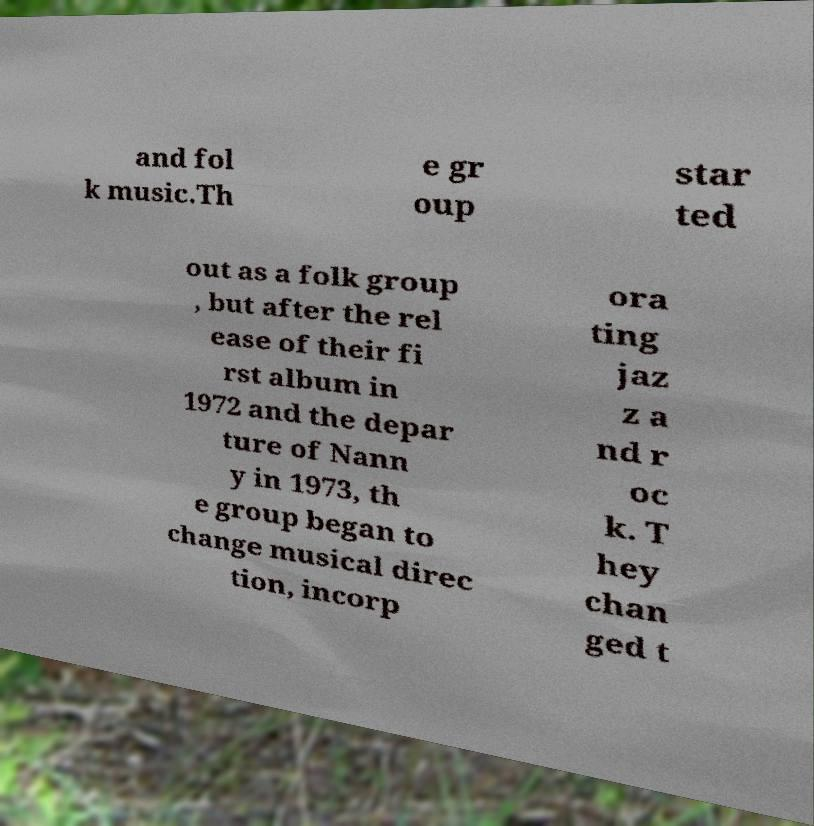I need the written content from this picture converted into text. Can you do that? and fol k music.Th e gr oup star ted out as a folk group , but after the rel ease of their fi rst album in 1972 and the depar ture of Nann y in 1973, th e group began to change musical direc tion, incorp ora ting jaz z a nd r oc k. T hey chan ged t 